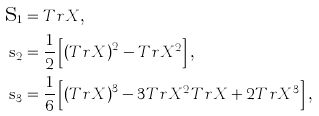<formula> <loc_0><loc_0><loc_500><loc_500>\mbox s _ { 1 } & = T r X \text {, } \\ \mbox s _ { 2 } & = \frac { 1 } { 2 } \left [ \left ( T r X \right ) ^ { 2 } - T r X ^ { 2 } \right ] \text {, } \\ \mbox s _ { 3 } & = \frac { 1 } { 6 } \left [ \left ( T r X \right ) ^ { 3 } - 3 T r X ^ { 2 } T r X + 2 T r X ^ { 3 } \right ] \text {, }</formula> 